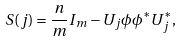<formula> <loc_0><loc_0><loc_500><loc_500>S ( j ) = \frac { n } { m } I _ { m } - U _ { j } \phi \phi ^ { \ast } U ^ { \ast } _ { j } ,</formula> 